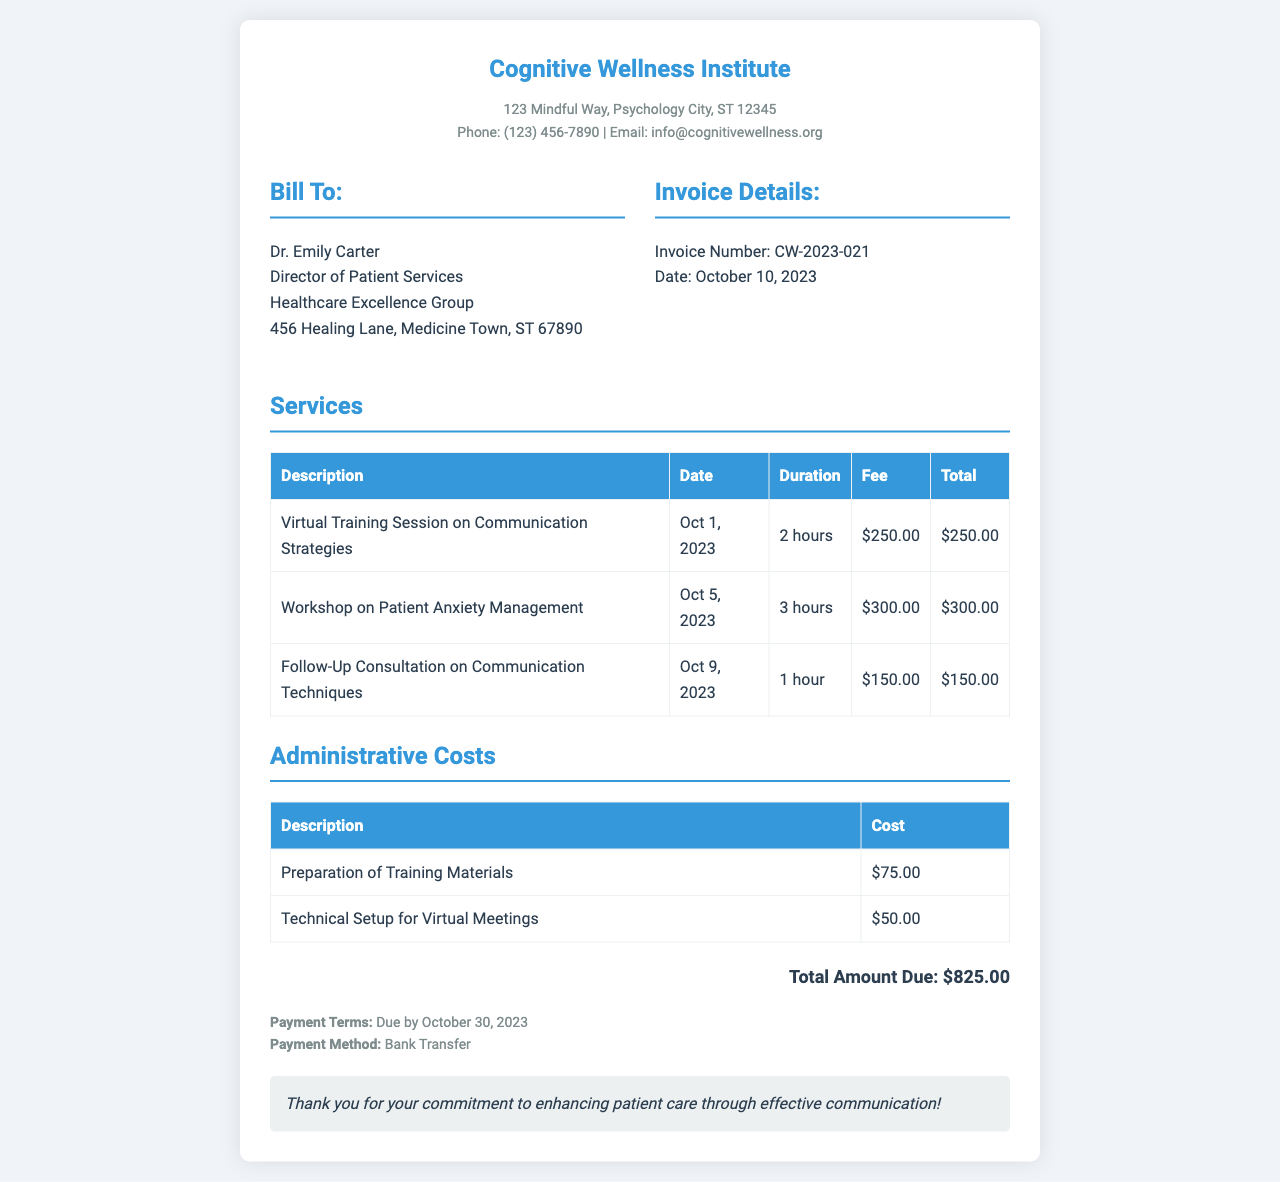What is the invoice number? The invoice number is a unique identifier for the invoice provided in the document, which is CW-2023-021.
Answer: CW-2023-021 Who is the recipient of the invoice? The recipient is the individual or organization being billed, stated in the document as Dr. Emily Carter.
Answer: Dr. Emily Carter What is the date of the first virtual training session? This refers to when the initial training session occurred, which is mentioned as October 1, 2023, in the services section.
Answer: October 1, 2023 What is the total amount due? The total amount due summarizes the total cost for services and administrative costs, provided at the end of the document as $825.00.
Answer: $825.00 How many hours was the workshop on patient anxiety management? This refers to the duration of the specific workshop mentioned in the services, which is 3 hours.
Answer: 3 hours What is the payment due date? The payment due date indicates when the payment should be completed, specified in the document as October 30, 2023.
Answer: October 30, 2023 What is the cost for technical setup for virtual meetings? This refers to the specific administrative cost listed in the document, which is $50.00.
Answer: $50.00 How many services are listed in total? This question asks for the count of distinct services rendered as detailed in the services section of the invoice.
Answer: 3 